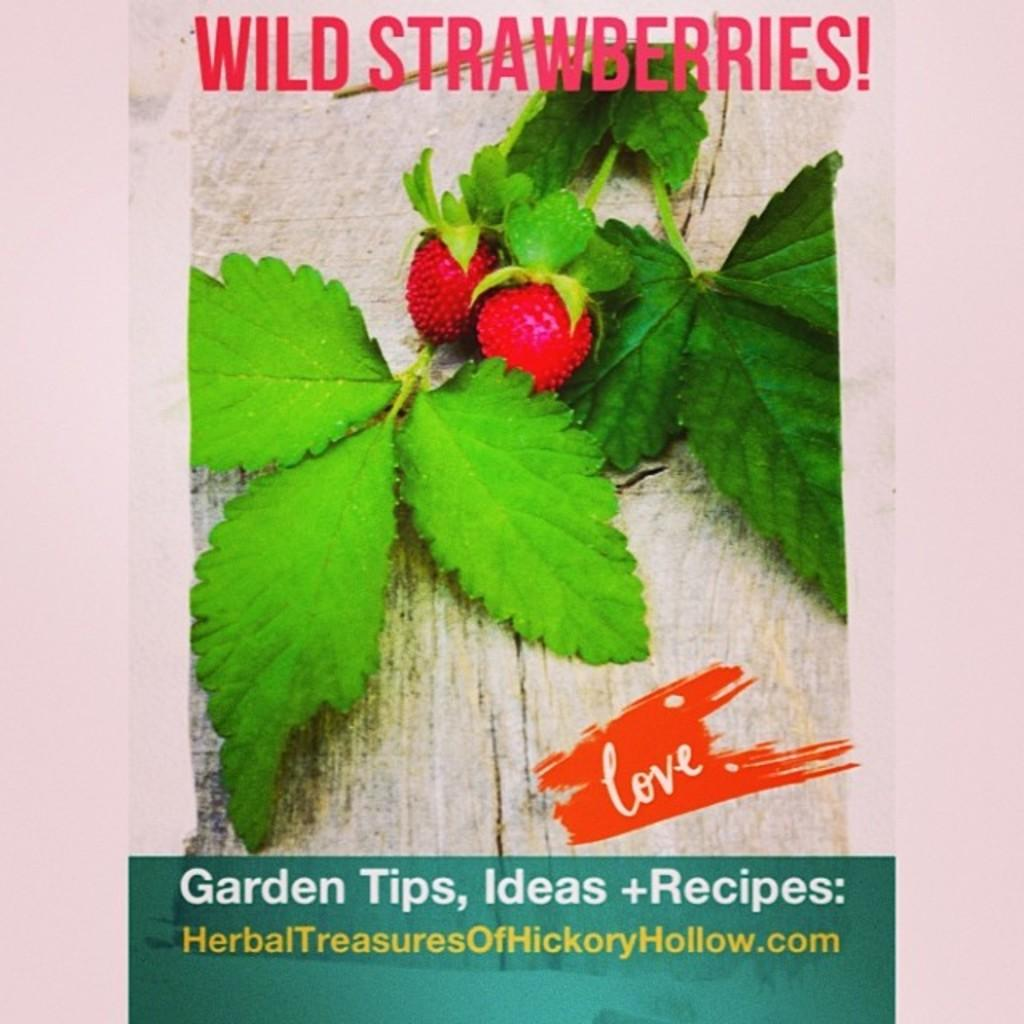What type of visual is the image in question? The image is a poster. Where on the poster is text located? There is text on the top and bottom of the poster. What types of images can be seen on the poster? The poster contains images of leaves and fruits. What is the limit or rule for the number of springs on the poster? There is no mention of springs or any limit or rule regarding them on the poster. 